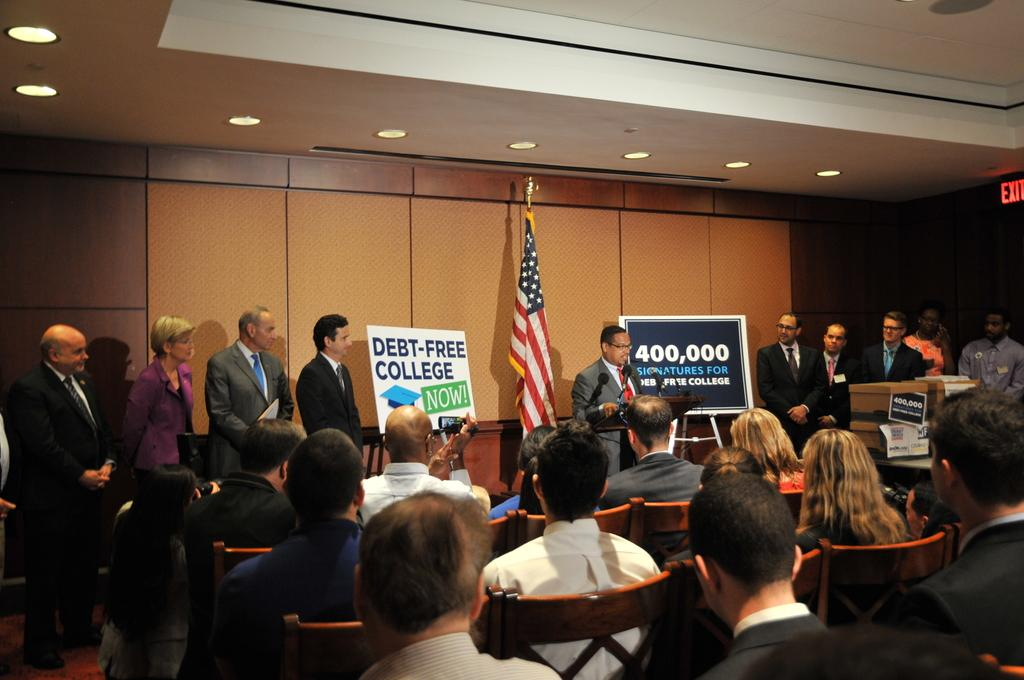Who or what can be seen in the image? There are people in the image. What objects are present in the image? There are boards, a poster, a flag, chairs, a stand, an exit board, and ceiling lights in the image. What is the purpose of the boards in the image? The boards may be used for displaying information or as a surface for writing or drawing. How are the chairs being used in the image? Some people are sitting on chairs in the image. What type of magic is being performed in the image? There is no magic or magical activity present in the image. What time of day is it in the image? The time of day cannot be determined from the image alone. 